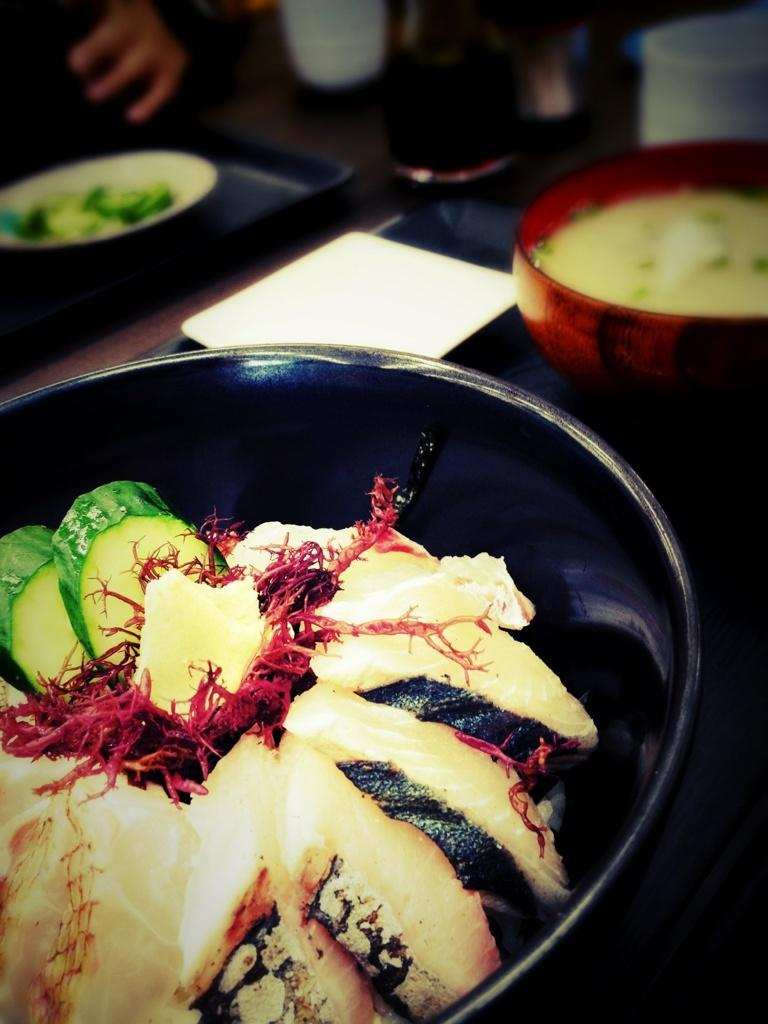What is in the bowl that is visible in the image? There are food items in a bowl in the image. What other dish is present in the image? There is a plate in the image. What is used to carry the dishes in the image? There is a tray in the image. Can you describe any other objects visible in the image? There are other objects visible in the image, but their specific details are not mentioned in the provided facts. What is the condition of the top part of the image? The top of the image has a blurred view. How many cherries are on the hat in the image? There is no hat or cherries present in the image. 